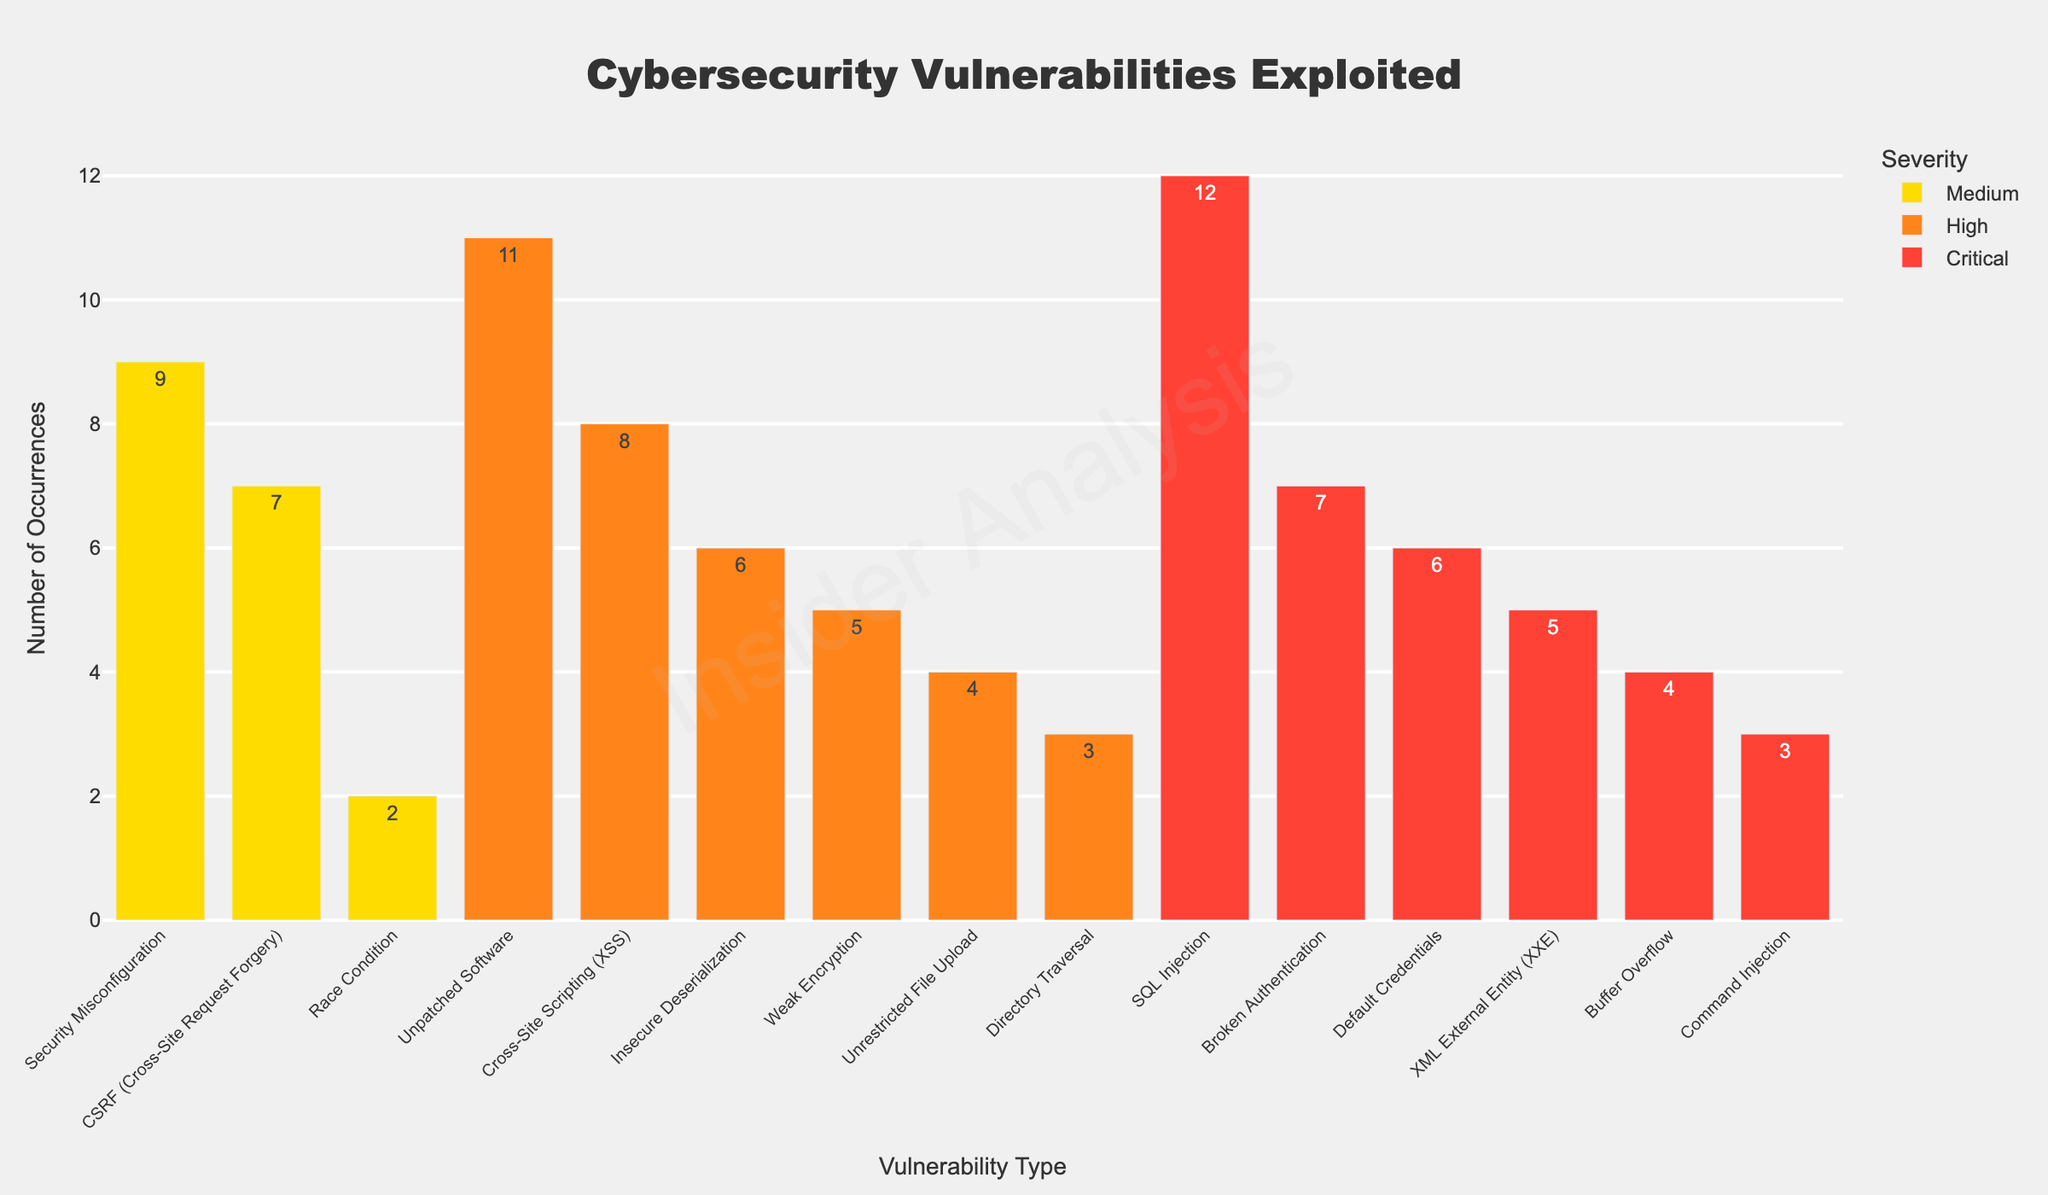What is the most frequently exploited vulnerability in the 'Critical' severity category? Identify the bar with the highest count in the 'Critical' severity segment, which is colored red. 'SQL Injection' has the highest value of 12.
Answer: SQL Injection Which 'High' severity vulnerability has the lowest occurrence? Look at the vulnerabilities in the 'High' severity category, colored orange. 'Directory Traversal' has the lowest count of 3.
Answer: Directory Traversal How many total 'Medium' severity vulnerabilities are there? Sum the counts of bars in the 'Medium' severity category, colored yellow: Security Misconfiguration (9) + CSRF (7) + Race Condition (2) = 18.
Answer: 18 Between 'Insecure Deserialization' and 'Default Credentials', which one has a higher count and by how much? Compare the counts: 'Insecure Deserialization' (6) vs. 'Default Credentials' (6). Both have the same count, so the difference is 0.
Answer: They have the same count, 0 difference Which severity category has the highest total number of vulnerabilities exploited? Sum the counts for each severity: Critical = 12 + 7 + 5 + 4 + 6 + 3 = 37, High = 8 + 6 + 11 + 3 + 5 + 4 = 37, Medium = 9 + 7 + 2 = 18. Both Critical and High have 37.
Answer: Critical and High What is the combined count for 'Unpatched Software' and 'Weak Encryption'? Add the counts for 'Unpatched Software' (11) and 'Weak Encryption' (5). 11 + 5 = 16.
Answer: 16 Which 'Critical' severity vulnerability has the second-lowest occurrence? Look at the counts of 'Critical' vulnerabilities, excluding the lowest. The sorted counts are 12, 7, 6, 5, 4, 3, with 'Buffer Overflow' at 4 being second-lowest.
Answer: Buffer Overflow By how much does 'Cross-Site Scripting (XSS)' exceed 'Unrestricted File Upload' in count? Compare the counts: 'Cross-Site Scripting (XSS)' (8) and 'Unrestricted File Upload' (4). The difference is 8 - 4 = 4.
Answer: 4 What is the average number of occurrences for 'High' severity vulnerabilities? Sum the counts of 'High' severity vulnerabilities and divide by the number of vulnerabilities: (8 + 6 + 11 + 3 + 5 + 4) / 6 = 37 / 6 ≈ 6.17.
Answer: 6.17 